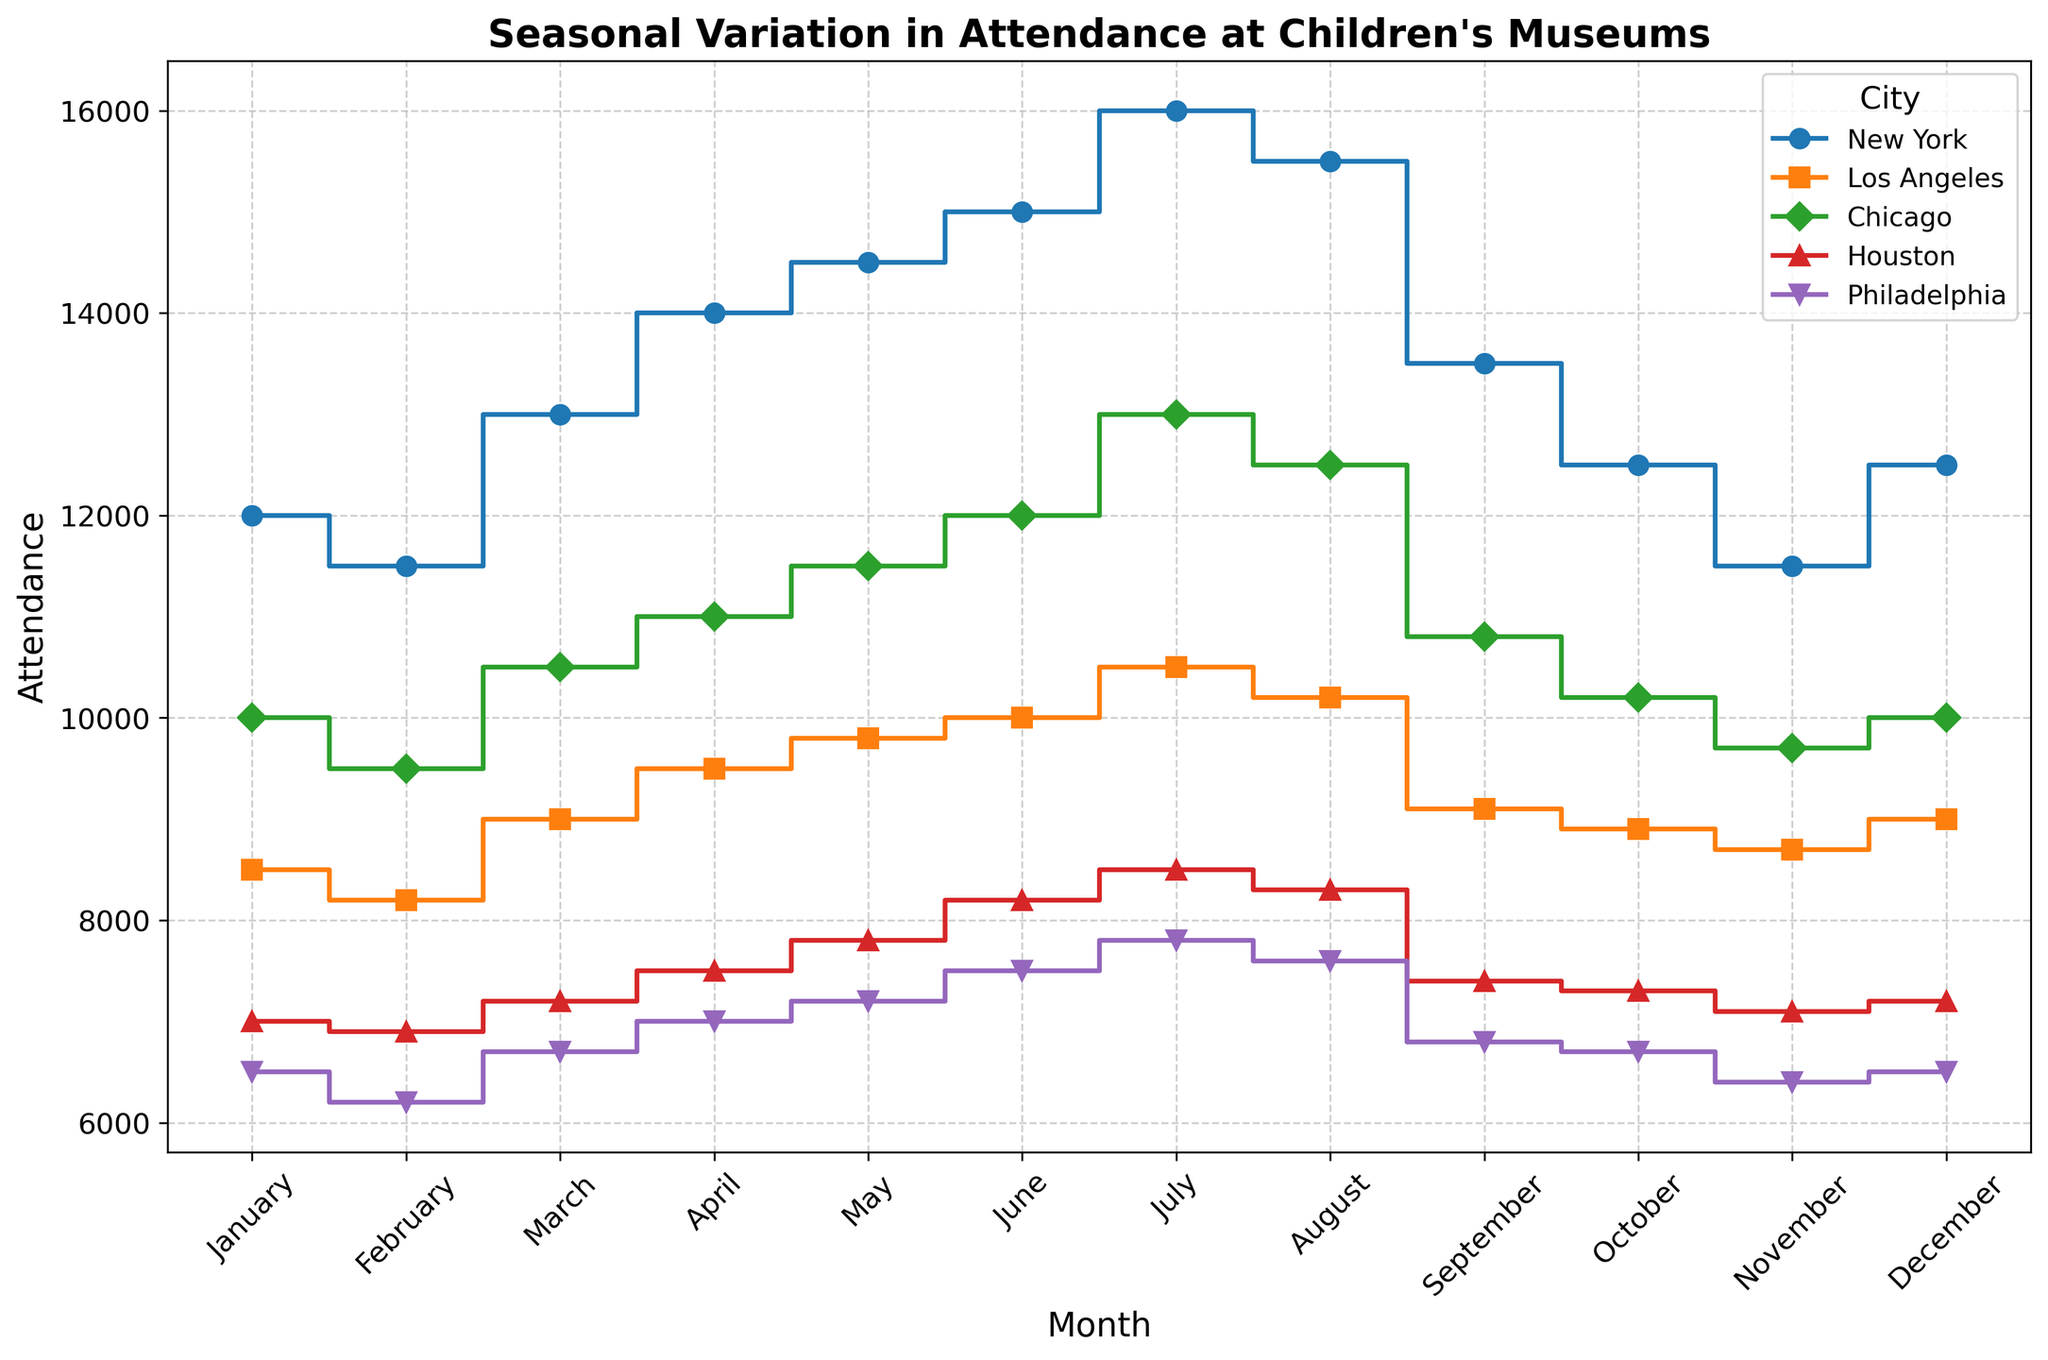Which city has the highest attendance in July? The stairs plot shows that July's attendance values are the highest point for each city. By comparing the heights of the points in July, New York has the highest value.
Answer: New York What is the difference in attendance between New York and Philadelphia in June? To find the difference, check the values for New York and Philadelphia in June: New York (15,000) and Philadelphia (7,500). Subtract Philadelphia's attendance from New York's attendance: 15,000 - 7,500 = 7,500.
Answer: 7,500 Which months have the highest attendance for Los Angeles? To answer this, examine the plot for Los Angeles and look for the highest point. Both June and July have nearly similar and the highest values for Los Angeles.
Answer: June and July In which month is Houston's attendance the lowest? Check the visual points for Houston across all months and compare. Houston shows the lowest attendance point in January.
Answer: January What's the average attendance for Chicago in the months of April, May, and June? Find the attendance values for Chicago in April (11,000), May (11,500), and June (12,000). Sum these values: 11,000 + 11,500 + 12,000 = 34,500. Then, divide by 3 for the average: 34,500 / 3 = 11,500.
Answer: 11,500 Is the attendance in August higher than in June for Philadelphia? Compare the visual heights of the points for Philadelphia in August and June. In June, it's 7,500, and in August, it's 7,600. Thus, August's attendance is slightly higher than June's.
Answer: Yes Which city has the smallest change in attendance from January to December? Compare the difference in attendance for each city between January and December. For New York: 12,000 - 12,500 = -500. For Los Angeles: 8,500 - 9,000 = -500. For Chicago: 10,000 - 10,000 = 0. For Houston: 7,000 - 7,200 = -200. For Philadelphia: 6,500 - 6,500 = 0. Both Chicago and Philadelphia have the smallest change.
Answer: Chicago and Philadelphia What is the combined attendance for all cities in March? Sum the March attendance for each city. New York (13,000), Los Angeles (9,000), Chicago (10,500), Houston (7,200), and Philadelphia (6,700). Combined: 13,000 + 9,000 + 10,500 + 7,200 + 6,700 = 46,400.
Answer: 46,400 In which month does Philadelphia catch up with Houston in attendance after initially having lower attendance? Examine the plot for Philadelphia and Houston where initially Philadelphia's points are lower. Find the first month where they become equal or Philadelphia surpasses Houston. This happens in December, where both cities have equal attendance (6,500).
Answer: December 